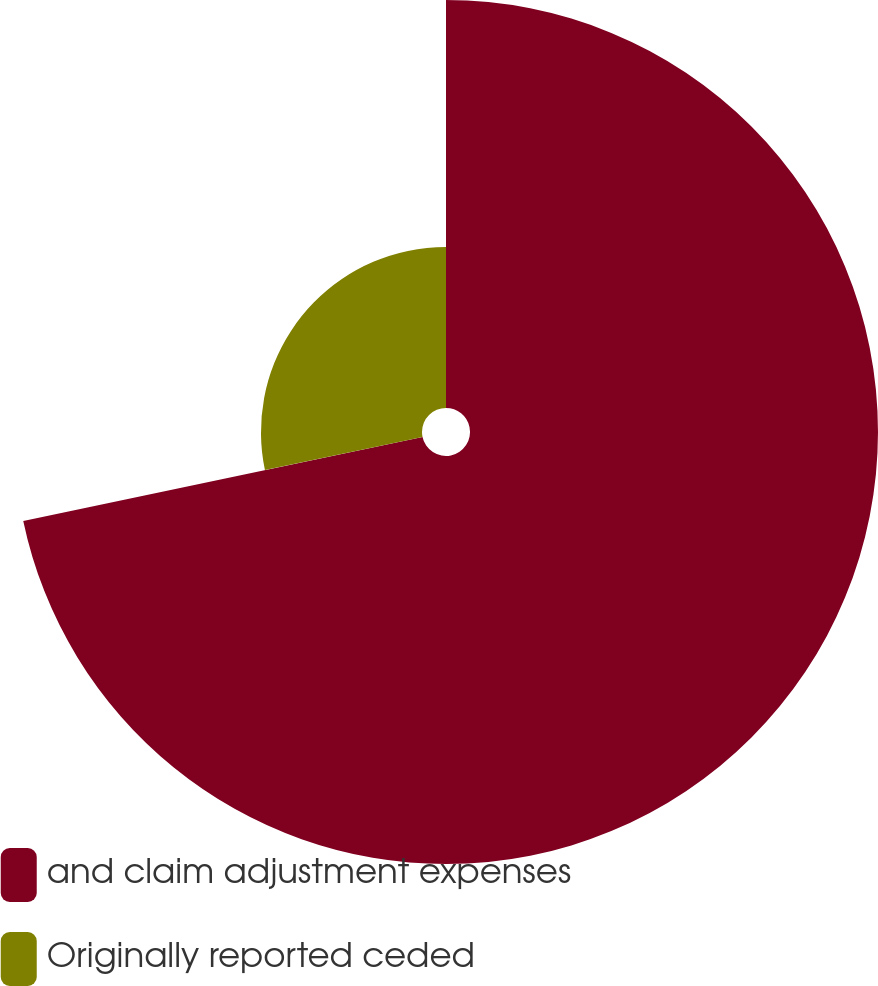Convert chart to OTSL. <chart><loc_0><loc_0><loc_500><loc_500><pie_chart><fcel>and claim adjustment expenses<fcel>Originally reported ceded<nl><fcel>71.7%<fcel>28.3%<nl></chart> 